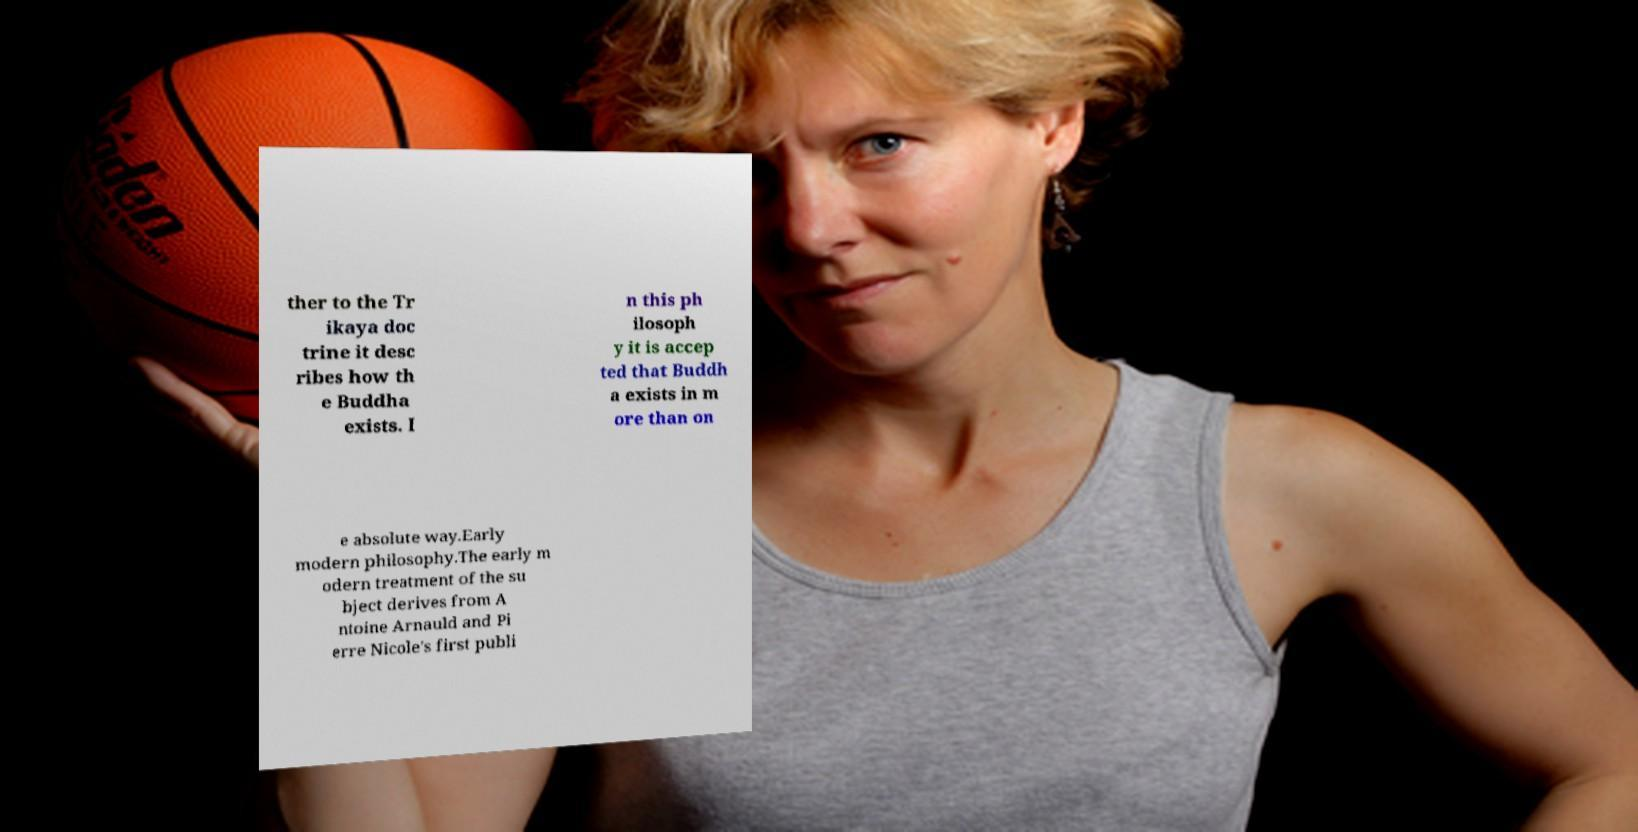Please read and relay the text visible in this image. What does it say? ther to the Tr ikaya doc trine it desc ribes how th e Buddha exists. I n this ph ilosoph y it is accep ted that Buddh a exists in m ore than on e absolute way.Early modern philosophy.The early m odern treatment of the su bject derives from A ntoine Arnauld and Pi erre Nicole's first publi 